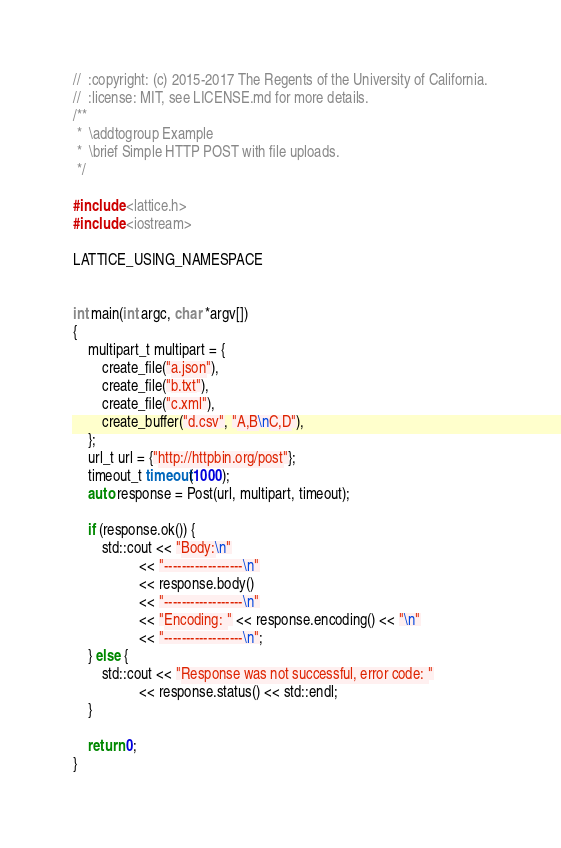Convert code to text. <code><loc_0><loc_0><loc_500><loc_500><_C++_>//  :copyright: (c) 2015-2017 The Regents of the University of California.
//  :license: MIT, see LICENSE.md for more details.
/**
 *  \addtogroup Example
 *  \brief Simple HTTP POST with file uploads.
 */

#include <lattice.h>
#include <iostream>

LATTICE_USING_NAMESPACE


int main(int argc, char *argv[])
{
    multipart_t multipart = {
        create_file("a.json"),
        create_file("b.txt"),
        create_file("c.xml"),
        create_buffer("d.csv", "A,B\nC,D"),
    };
    url_t url = {"http://httpbin.org/post"};
    timeout_t timeout(1000);
    auto response = Post(url, multipart, timeout);

    if (response.ok()) {
        std::cout << "Body:\n"
                  << "------------------\n"
                  << response.body()
                  << "------------------\n"
                  << "Encoding: " << response.encoding() << "\n"
                  << "------------------\n";
    } else {
        std::cout << "Response was not successful, error code: "
                  << response.status() << std::endl;
    }

    return 0;
}
</code> 